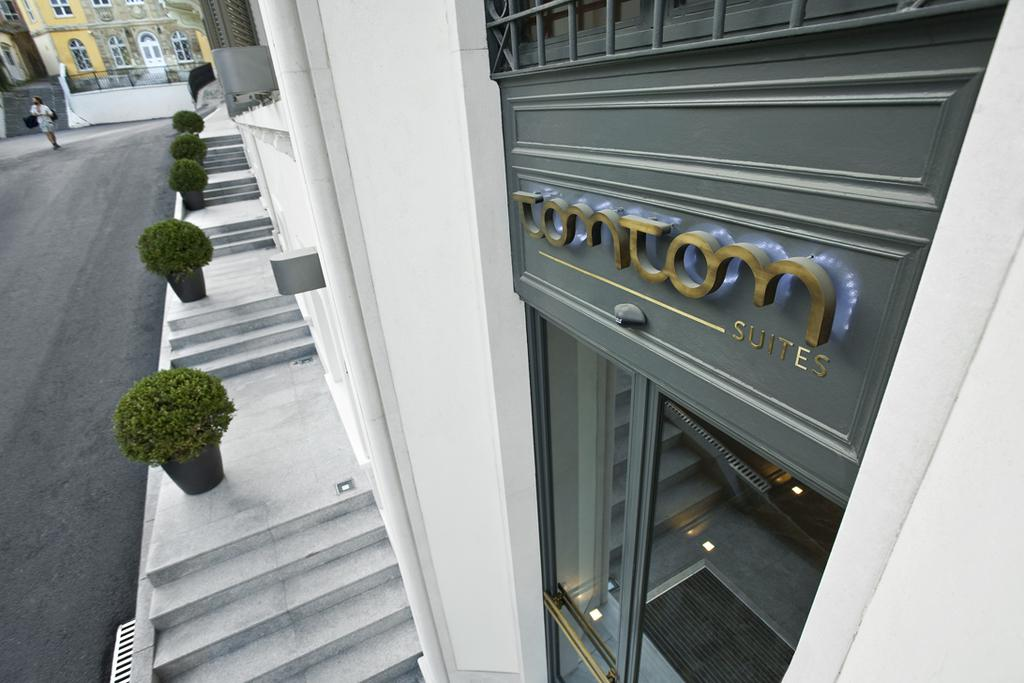<image>
Present a compact description of the photo's key features. A store that is named Tomtom, which is found by stairs. 